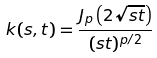Convert formula to latex. <formula><loc_0><loc_0><loc_500><loc_500>k ( s , t ) = \frac { J _ { p } \left ( 2 \sqrt { s t } \right ) } { ( s t ) ^ { p / 2 } }</formula> 